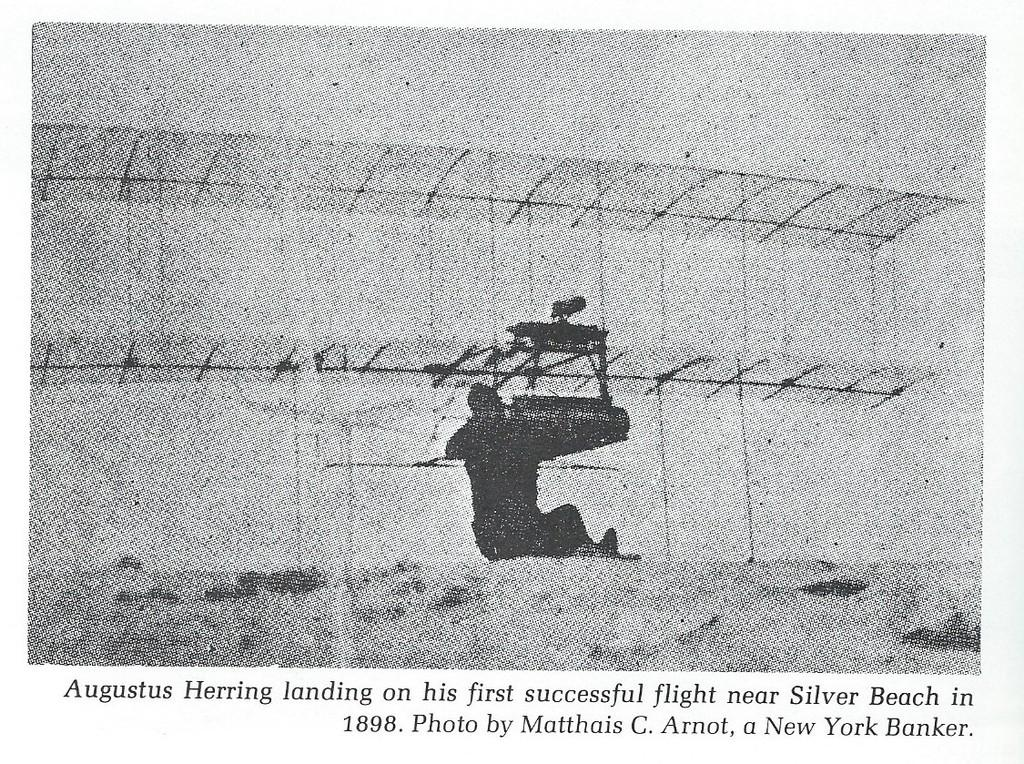Who or what is the main subject in the center of the image? There is a person in the center of the image. What can be found at the bottom of the image? There is text at the bottom of the image. What color is the background of the image? The background of the image is white. What type of ink is being used for the voyage in the image? There is no voyage or ink present in the image; it features a person and text on a white background. 